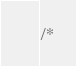<code> <loc_0><loc_0><loc_500><loc_500><_Java_>/*</code> 